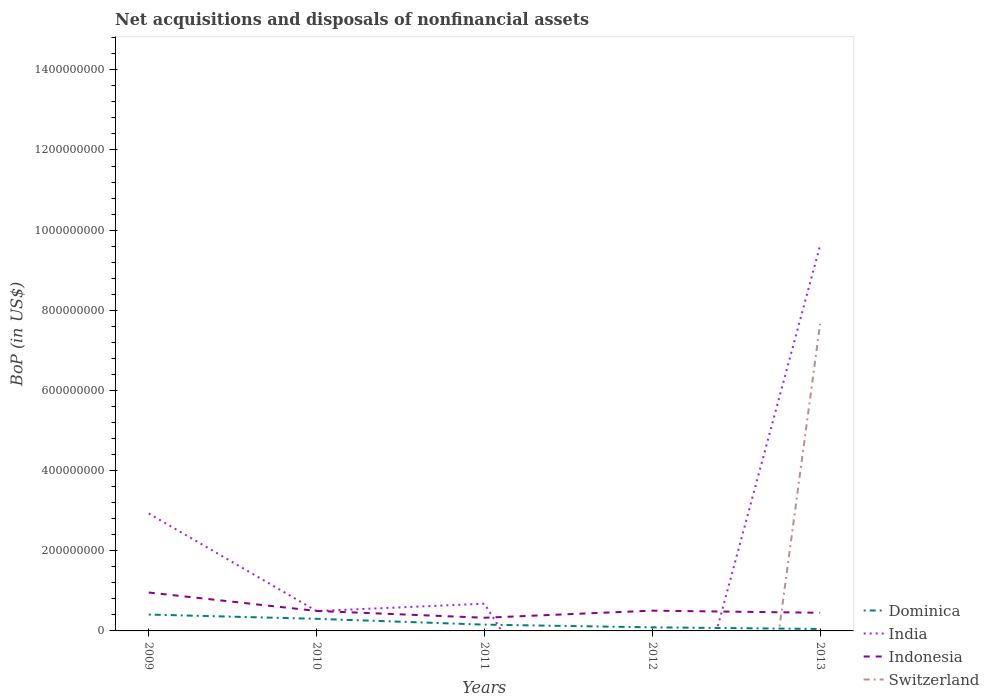How many different coloured lines are there?
Offer a terse response. 4. Across all years, what is the maximum Balance of Payments in Dominica?
Ensure brevity in your answer.  4.89e+06. What is the total Balance of Payments in Indonesia in the graph?
Keep it short and to the point. 5.27e+06. What is the difference between the highest and the second highest Balance of Payments in Switzerland?
Provide a succinct answer. 7.66e+08. What is the difference between the highest and the lowest Balance of Payments in Switzerland?
Your response must be concise. 1. How many years are there in the graph?
Keep it short and to the point. 5. What is the difference between two consecutive major ticks on the Y-axis?
Ensure brevity in your answer.  2.00e+08. Are the values on the major ticks of Y-axis written in scientific E-notation?
Provide a short and direct response. No. Does the graph contain any zero values?
Your answer should be compact. Yes. Does the graph contain grids?
Offer a terse response. No. Where does the legend appear in the graph?
Your answer should be compact. Bottom right. What is the title of the graph?
Your response must be concise. Net acquisitions and disposals of nonfinancial assets. Does "Heavily indebted poor countries" appear as one of the legend labels in the graph?
Provide a succinct answer. No. What is the label or title of the Y-axis?
Give a very brief answer. BoP (in US$). What is the BoP (in US$) in Dominica in 2009?
Your response must be concise. 4.08e+07. What is the BoP (in US$) of India in 2009?
Provide a short and direct response. 2.93e+08. What is the BoP (in US$) in Indonesia in 2009?
Offer a very short reply. 9.58e+07. What is the BoP (in US$) of Dominica in 2010?
Ensure brevity in your answer.  3.02e+07. What is the BoP (in US$) of India in 2010?
Keep it short and to the point. 4.97e+07. What is the BoP (in US$) in Indonesia in 2010?
Your answer should be very brief. 4.98e+07. What is the BoP (in US$) of Switzerland in 2010?
Your response must be concise. 0. What is the BoP (in US$) in Dominica in 2011?
Offer a very short reply. 1.57e+07. What is the BoP (in US$) in India in 2011?
Offer a very short reply. 6.79e+07. What is the BoP (in US$) in Indonesia in 2011?
Your response must be concise. 3.29e+07. What is the BoP (in US$) in Switzerland in 2011?
Make the answer very short. 0. What is the BoP (in US$) in Dominica in 2012?
Your response must be concise. 8.93e+06. What is the BoP (in US$) in Indonesia in 2012?
Ensure brevity in your answer.  5.06e+07. What is the BoP (in US$) in Dominica in 2013?
Give a very brief answer. 4.89e+06. What is the BoP (in US$) in India in 2013?
Your response must be concise. 9.62e+08. What is the BoP (in US$) in Indonesia in 2013?
Give a very brief answer. 4.53e+07. What is the BoP (in US$) in Switzerland in 2013?
Ensure brevity in your answer.  7.66e+08. Across all years, what is the maximum BoP (in US$) in Dominica?
Offer a very short reply. 4.08e+07. Across all years, what is the maximum BoP (in US$) in India?
Keep it short and to the point. 9.62e+08. Across all years, what is the maximum BoP (in US$) in Indonesia?
Provide a succinct answer. 9.58e+07. Across all years, what is the maximum BoP (in US$) of Switzerland?
Make the answer very short. 7.66e+08. Across all years, what is the minimum BoP (in US$) of Dominica?
Your response must be concise. 4.89e+06. Across all years, what is the minimum BoP (in US$) in Indonesia?
Provide a succinct answer. 3.29e+07. Across all years, what is the minimum BoP (in US$) of Switzerland?
Your answer should be compact. 0. What is the total BoP (in US$) in Dominica in the graph?
Give a very brief answer. 1.01e+08. What is the total BoP (in US$) of India in the graph?
Offer a very short reply. 1.37e+09. What is the total BoP (in US$) in Indonesia in the graph?
Offer a terse response. 2.74e+08. What is the total BoP (in US$) of Switzerland in the graph?
Make the answer very short. 7.66e+08. What is the difference between the BoP (in US$) in Dominica in 2009 and that in 2010?
Offer a very short reply. 1.06e+07. What is the difference between the BoP (in US$) of India in 2009 and that in 2010?
Provide a short and direct response. 2.43e+08. What is the difference between the BoP (in US$) in Indonesia in 2009 and that in 2010?
Offer a very short reply. 4.60e+07. What is the difference between the BoP (in US$) of Dominica in 2009 and that in 2011?
Keep it short and to the point. 2.51e+07. What is the difference between the BoP (in US$) of India in 2009 and that in 2011?
Your response must be concise. 2.25e+08. What is the difference between the BoP (in US$) in Indonesia in 2009 and that in 2011?
Keep it short and to the point. 6.29e+07. What is the difference between the BoP (in US$) of Dominica in 2009 and that in 2012?
Ensure brevity in your answer.  3.19e+07. What is the difference between the BoP (in US$) in Indonesia in 2009 and that in 2012?
Provide a short and direct response. 4.53e+07. What is the difference between the BoP (in US$) in Dominica in 2009 and that in 2013?
Provide a succinct answer. 3.59e+07. What is the difference between the BoP (in US$) of India in 2009 and that in 2013?
Offer a very short reply. -6.69e+08. What is the difference between the BoP (in US$) in Indonesia in 2009 and that in 2013?
Your answer should be compact. 5.05e+07. What is the difference between the BoP (in US$) in Dominica in 2010 and that in 2011?
Your answer should be compact. 1.45e+07. What is the difference between the BoP (in US$) of India in 2010 and that in 2011?
Provide a succinct answer. -1.83e+07. What is the difference between the BoP (in US$) in Indonesia in 2010 and that in 2011?
Provide a succinct answer. 1.70e+07. What is the difference between the BoP (in US$) in Dominica in 2010 and that in 2012?
Ensure brevity in your answer.  2.13e+07. What is the difference between the BoP (in US$) of Indonesia in 2010 and that in 2012?
Give a very brief answer. -7.19e+05. What is the difference between the BoP (in US$) in Dominica in 2010 and that in 2013?
Offer a terse response. 2.53e+07. What is the difference between the BoP (in US$) of India in 2010 and that in 2013?
Give a very brief answer. -9.12e+08. What is the difference between the BoP (in US$) of Indonesia in 2010 and that in 2013?
Provide a short and direct response. 4.55e+06. What is the difference between the BoP (in US$) of Dominica in 2011 and that in 2012?
Offer a very short reply. 6.75e+06. What is the difference between the BoP (in US$) in Indonesia in 2011 and that in 2012?
Your answer should be compact. -1.77e+07. What is the difference between the BoP (in US$) in Dominica in 2011 and that in 2013?
Make the answer very short. 1.08e+07. What is the difference between the BoP (in US$) of India in 2011 and that in 2013?
Provide a short and direct response. -8.94e+08. What is the difference between the BoP (in US$) in Indonesia in 2011 and that in 2013?
Keep it short and to the point. -1.24e+07. What is the difference between the BoP (in US$) in Dominica in 2012 and that in 2013?
Ensure brevity in your answer.  4.05e+06. What is the difference between the BoP (in US$) in Indonesia in 2012 and that in 2013?
Keep it short and to the point. 5.27e+06. What is the difference between the BoP (in US$) in Dominica in 2009 and the BoP (in US$) in India in 2010?
Ensure brevity in your answer.  -8.83e+06. What is the difference between the BoP (in US$) of Dominica in 2009 and the BoP (in US$) of Indonesia in 2010?
Keep it short and to the point. -9.01e+06. What is the difference between the BoP (in US$) in India in 2009 and the BoP (in US$) in Indonesia in 2010?
Keep it short and to the point. 2.43e+08. What is the difference between the BoP (in US$) in Dominica in 2009 and the BoP (in US$) in India in 2011?
Your answer should be compact. -2.71e+07. What is the difference between the BoP (in US$) in Dominica in 2009 and the BoP (in US$) in Indonesia in 2011?
Provide a short and direct response. 7.95e+06. What is the difference between the BoP (in US$) of India in 2009 and the BoP (in US$) of Indonesia in 2011?
Keep it short and to the point. 2.60e+08. What is the difference between the BoP (in US$) of Dominica in 2009 and the BoP (in US$) of Indonesia in 2012?
Give a very brief answer. -9.73e+06. What is the difference between the BoP (in US$) in India in 2009 and the BoP (in US$) in Indonesia in 2012?
Make the answer very short. 2.42e+08. What is the difference between the BoP (in US$) of Dominica in 2009 and the BoP (in US$) of India in 2013?
Keep it short and to the point. -9.21e+08. What is the difference between the BoP (in US$) in Dominica in 2009 and the BoP (in US$) in Indonesia in 2013?
Your answer should be compact. -4.46e+06. What is the difference between the BoP (in US$) of Dominica in 2009 and the BoP (in US$) of Switzerland in 2013?
Make the answer very short. -7.25e+08. What is the difference between the BoP (in US$) in India in 2009 and the BoP (in US$) in Indonesia in 2013?
Give a very brief answer. 2.48e+08. What is the difference between the BoP (in US$) in India in 2009 and the BoP (in US$) in Switzerland in 2013?
Offer a very short reply. -4.73e+08. What is the difference between the BoP (in US$) of Indonesia in 2009 and the BoP (in US$) of Switzerland in 2013?
Give a very brief answer. -6.70e+08. What is the difference between the BoP (in US$) of Dominica in 2010 and the BoP (in US$) of India in 2011?
Offer a very short reply. -3.77e+07. What is the difference between the BoP (in US$) of Dominica in 2010 and the BoP (in US$) of Indonesia in 2011?
Offer a terse response. -2.67e+06. What is the difference between the BoP (in US$) of India in 2010 and the BoP (in US$) of Indonesia in 2011?
Offer a terse response. 1.68e+07. What is the difference between the BoP (in US$) in Dominica in 2010 and the BoP (in US$) in Indonesia in 2012?
Your answer should be very brief. -2.04e+07. What is the difference between the BoP (in US$) in India in 2010 and the BoP (in US$) in Indonesia in 2012?
Provide a succinct answer. -9.03e+05. What is the difference between the BoP (in US$) of Dominica in 2010 and the BoP (in US$) of India in 2013?
Your response must be concise. -9.32e+08. What is the difference between the BoP (in US$) of Dominica in 2010 and the BoP (in US$) of Indonesia in 2013?
Make the answer very short. -1.51e+07. What is the difference between the BoP (in US$) in Dominica in 2010 and the BoP (in US$) in Switzerland in 2013?
Your answer should be very brief. -7.36e+08. What is the difference between the BoP (in US$) in India in 2010 and the BoP (in US$) in Indonesia in 2013?
Ensure brevity in your answer.  4.37e+06. What is the difference between the BoP (in US$) of India in 2010 and the BoP (in US$) of Switzerland in 2013?
Offer a very short reply. -7.17e+08. What is the difference between the BoP (in US$) in Indonesia in 2010 and the BoP (in US$) in Switzerland in 2013?
Offer a terse response. -7.16e+08. What is the difference between the BoP (in US$) of Dominica in 2011 and the BoP (in US$) of Indonesia in 2012?
Offer a very short reply. -3.49e+07. What is the difference between the BoP (in US$) of India in 2011 and the BoP (in US$) of Indonesia in 2012?
Your response must be concise. 1.74e+07. What is the difference between the BoP (in US$) in Dominica in 2011 and the BoP (in US$) in India in 2013?
Offer a very short reply. -9.46e+08. What is the difference between the BoP (in US$) of Dominica in 2011 and the BoP (in US$) of Indonesia in 2013?
Provide a short and direct response. -2.96e+07. What is the difference between the BoP (in US$) of Dominica in 2011 and the BoP (in US$) of Switzerland in 2013?
Give a very brief answer. -7.51e+08. What is the difference between the BoP (in US$) in India in 2011 and the BoP (in US$) in Indonesia in 2013?
Your answer should be compact. 2.26e+07. What is the difference between the BoP (in US$) in India in 2011 and the BoP (in US$) in Switzerland in 2013?
Keep it short and to the point. -6.98e+08. What is the difference between the BoP (in US$) of Indonesia in 2011 and the BoP (in US$) of Switzerland in 2013?
Keep it short and to the point. -7.33e+08. What is the difference between the BoP (in US$) of Dominica in 2012 and the BoP (in US$) of India in 2013?
Provide a succinct answer. -9.53e+08. What is the difference between the BoP (in US$) in Dominica in 2012 and the BoP (in US$) in Indonesia in 2013?
Provide a succinct answer. -3.64e+07. What is the difference between the BoP (in US$) of Dominica in 2012 and the BoP (in US$) of Switzerland in 2013?
Offer a terse response. -7.57e+08. What is the difference between the BoP (in US$) of Indonesia in 2012 and the BoP (in US$) of Switzerland in 2013?
Your answer should be compact. -7.16e+08. What is the average BoP (in US$) in Dominica per year?
Your answer should be very brief. 2.01e+07. What is the average BoP (in US$) in India per year?
Your answer should be very brief. 2.74e+08. What is the average BoP (in US$) of Indonesia per year?
Give a very brief answer. 5.49e+07. What is the average BoP (in US$) in Switzerland per year?
Offer a terse response. 1.53e+08. In the year 2009, what is the difference between the BoP (in US$) in Dominica and BoP (in US$) in India?
Keep it short and to the point. -2.52e+08. In the year 2009, what is the difference between the BoP (in US$) of Dominica and BoP (in US$) of Indonesia?
Provide a short and direct response. -5.50e+07. In the year 2009, what is the difference between the BoP (in US$) of India and BoP (in US$) of Indonesia?
Offer a very short reply. 1.97e+08. In the year 2010, what is the difference between the BoP (in US$) in Dominica and BoP (in US$) in India?
Provide a succinct answer. -1.94e+07. In the year 2010, what is the difference between the BoP (in US$) in Dominica and BoP (in US$) in Indonesia?
Your answer should be compact. -1.96e+07. In the year 2010, what is the difference between the BoP (in US$) in India and BoP (in US$) in Indonesia?
Offer a terse response. -1.84e+05. In the year 2011, what is the difference between the BoP (in US$) of Dominica and BoP (in US$) of India?
Provide a succinct answer. -5.22e+07. In the year 2011, what is the difference between the BoP (in US$) in Dominica and BoP (in US$) in Indonesia?
Your response must be concise. -1.72e+07. In the year 2011, what is the difference between the BoP (in US$) of India and BoP (in US$) of Indonesia?
Provide a short and direct response. 3.50e+07. In the year 2012, what is the difference between the BoP (in US$) of Dominica and BoP (in US$) of Indonesia?
Offer a terse response. -4.16e+07. In the year 2013, what is the difference between the BoP (in US$) in Dominica and BoP (in US$) in India?
Provide a succinct answer. -9.57e+08. In the year 2013, what is the difference between the BoP (in US$) of Dominica and BoP (in US$) of Indonesia?
Offer a very short reply. -4.04e+07. In the year 2013, what is the difference between the BoP (in US$) of Dominica and BoP (in US$) of Switzerland?
Offer a very short reply. -7.61e+08. In the year 2013, what is the difference between the BoP (in US$) in India and BoP (in US$) in Indonesia?
Keep it short and to the point. 9.17e+08. In the year 2013, what is the difference between the BoP (in US$) in India and BoP (in US$) in Switzerland?
Your answer should be compact. 1.96e+08. In the year 2013, what is the difference between the BoP (in US$) in Indonesia and BoP (in US$) in Switzerland?
Ensure brevity in your answer.  -7.21e+08. What is the ratio of the BoP (in US$) in Dominica in 2009 to that in 2010?
Ensure brevity in your answer.  1.35. What is the ratio of the BoP (in US$) of India in 2009 to that in 2010?
Make the answer very short. 5.9. What is the ratio of the BoP (in US$) in Indonesia in 2009 to that in 2010?
Provide a short and direct response. 1.92. What is the ratio of the BoP (in US$) in Dominica in 2009 to that in 2011?
Your answer should be very brief. 2.6. What is the ratio of the BoP (in US$) of India in 2009 to that in 2011?
Your answer should be compact. 4.31. What is the ratio of the BoP (in US$) of Indonesia in 2009 to that in 2011?
Make the answer very short. 2.91. What is the ratio of the BoP (in US$) in Dominica in 2009 to that in 2012?
Ensure brevity in your answer.  4.57. What is the ratio of the BoP (in US$) of Indonesia in 2009 to that in 2012?
Offer a terse response. 1.9. What is the ratio of the BoP (in US$) in Dominica in 2009 to that in 2013?
Offer a very short reply. 8.35. What is the ratio of the BoP (in US$) in India in 2009 to that in 2013?
Keep it short and to the point. 0.3. What is the ratio of the BoP (in US$) of Indonesia in 2009 to that in 2013?
Give a very brief answer. 2.12. What is the ratio of the BoP (in US$) of Dominica in 2010 to that in 2011?
Keep it short and to the point. 1.93. What is the ratio of the BoP (in US$) in India in 2010 to that in 2011?
Your answer should be very brief. 0.73. What is the ratio of the BoP (in US$) in Indonesia in 2010 to that in 2011?
Provide a short and direct response. 1.52. What is the ratio of the BoP (in US$) in Dominica in 2010 to that in 2012?
Ensure brevity in your answer.  3.38. What is the ratio of the BoP (in US$) of Indonesia in 2010 to that in 2012?
Give a very brief answer. 0.99. What is the ratio of the BoP (in US$) in Dominica in 2010 to that in 2013?
Provide a short and direct response. 6.18. What is the ratio of the BoP (in US$) in India in 2010 to that in 2013?
Keep it short and to the point. 0.05. What is the ratio of the BoP (in US$) of Indonesia in 2010 to that in 2013?
Provide a succinct answer. 1.1. What is the ratio of the BoP (in US$) of Dominica in 2011 to that in 2012?
Offer a very short reply. 1.76. What is the ratio of the BoP (in US$) of Indonesia in 2011 to that in 2012?
Offer a terse response. 0.65. What is the ratio of the BoP (in US$) of Dominica in 2011 to that in 2013?
Your response must be concise. 3.21. What is the ratio of the BoP (in US$) of India in 2011 to that in 2013?
Your answer should be compact. 0.07. What is the ratio of the BoP (in US$) of Indonesia in 2011 to that in 2013?
Provide a short and direct response. 0.73. What is the ratio of the BoP (in US$) of Dominica in 2012 to that in 2013?
Your answer should be very brief. 1.83. What is the ratio of the BoP (in US$) in Indonesia in 2012 to that in 2013?
Your answer should be compact. 1.12. What is the difference between the highest and the second highest BoP (in US$) of Dominica?
Give a very brief answer. 1.06e+07. What is the difference between the highest and the second highest BoP (in US$) of India?
Your response must be concise. 6.69e+08. What is the difference between the highest and the second highest BoP (in US$) of Indonesia?
Keep it short and to the point. 4.53e+07. What is the difference between the highest and the lowest BoP (in US$) in Dominica?
Give a very brief answer. 3.59e+07. What is the difference between the highest and the lowest BoP (in US$) of India?
Provide a short and direct response. 9.62e+08. What is the difference between the highest and the lowest BoP (in US$) of Indonesia?
Provide a succinct answer. 6.29e+07. What is the difference between the highest and the lowest BoP (in US$) in Switzerland?
Your answer should be very brief. 7.66e+08. 